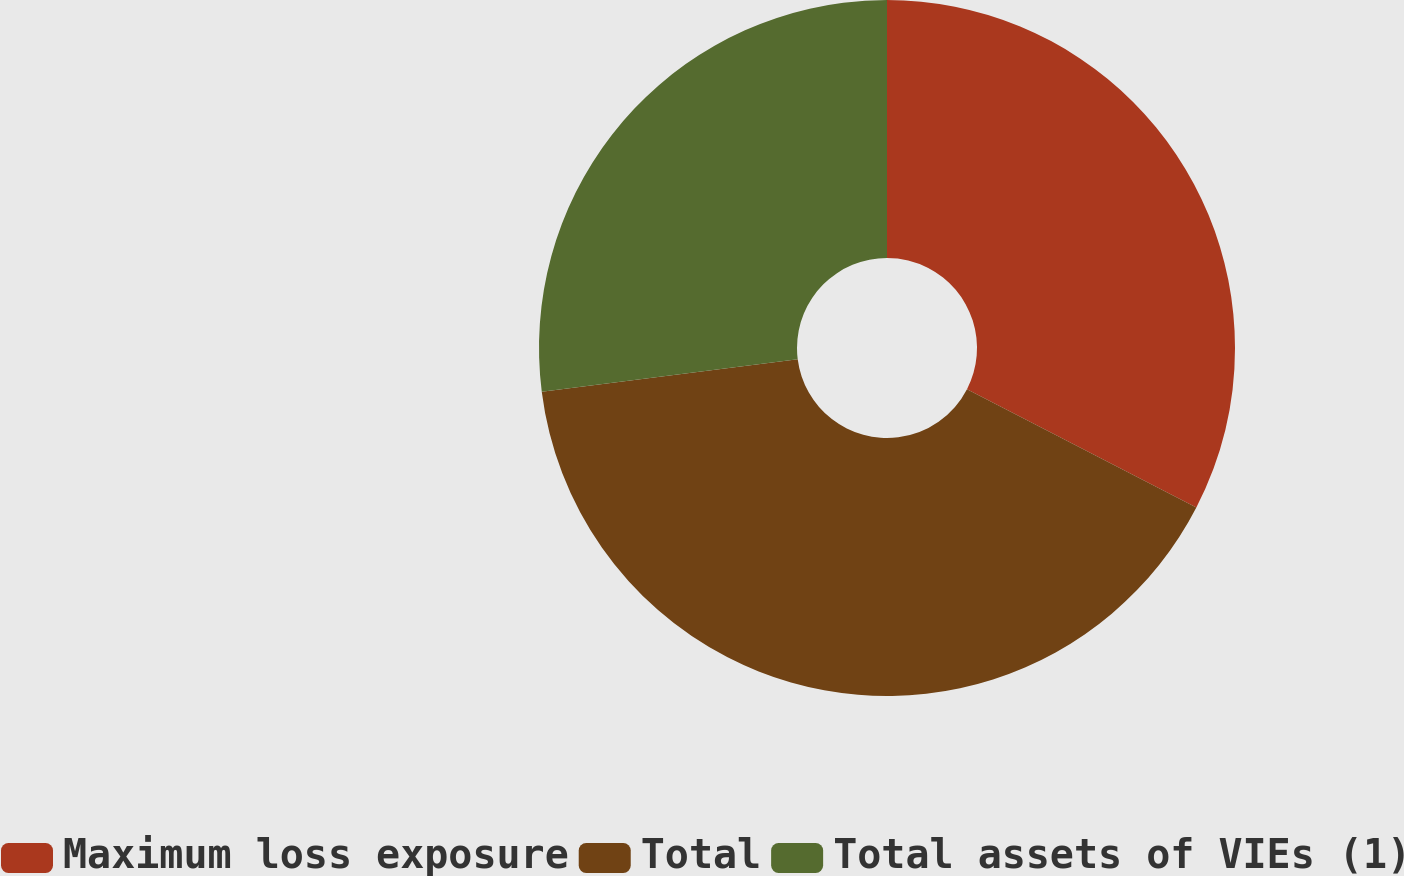Convert chart. <chart><loc_0><loc_0><loc_500><loc_500><pie_chart><fcel>Maximum loss exposure<fcel>Total<fcel>Total assets of VIEs (1)<nl><fcel>32.57%<fcel>40.42%<fcel>27.0%<nl></chart> 